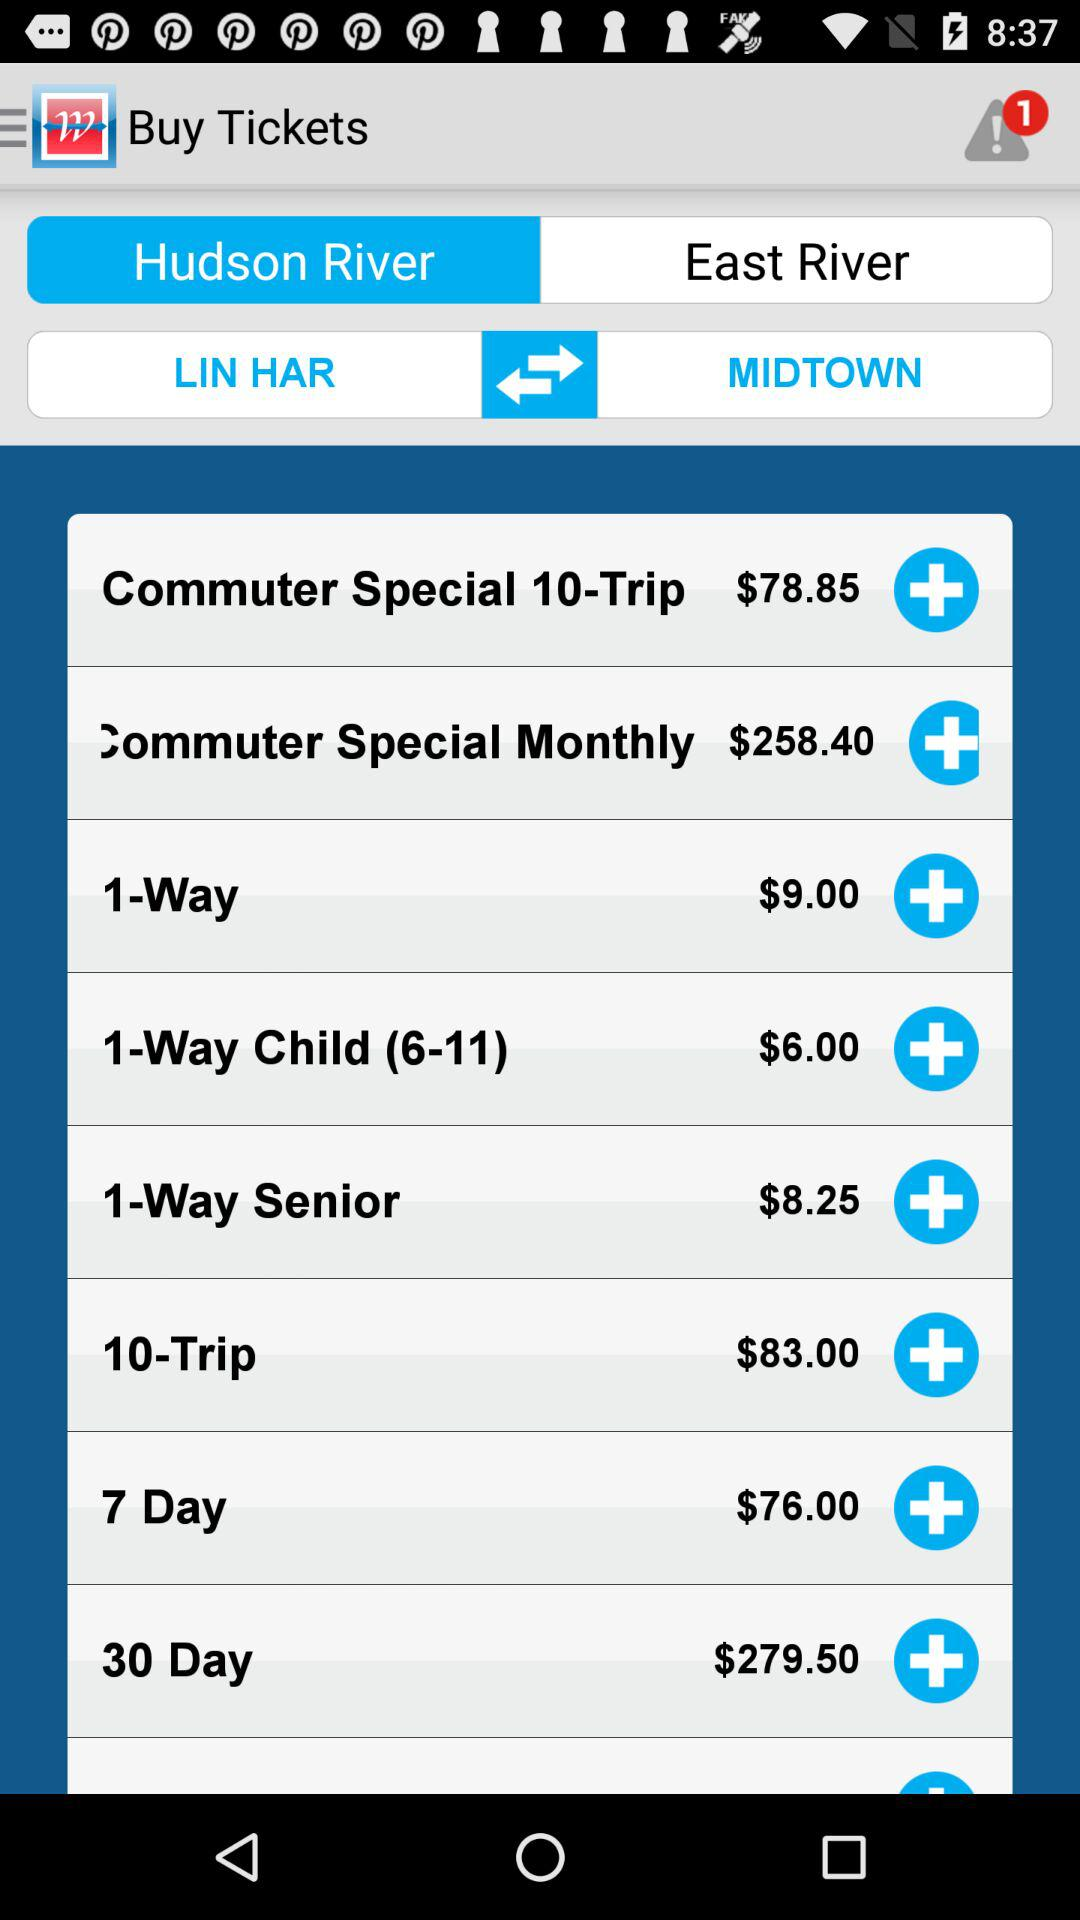What's the price of "30 Day"? The price of "30 Day" is $279.50. 